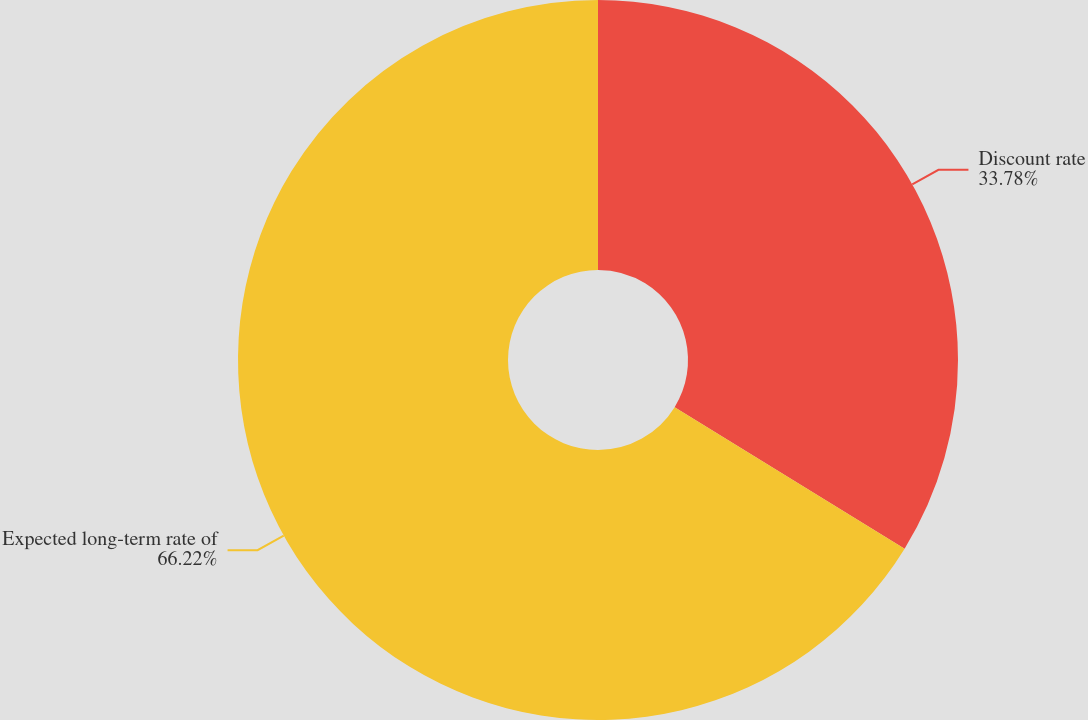Convert chart. <chart><loc_0><loc_0><loc_500><loc_500><pie_chart><fcel>Discount rate<fcel>Expected long-term rate of<nl><fcel>33.78%<fcel>66.22%<nl></chart> 